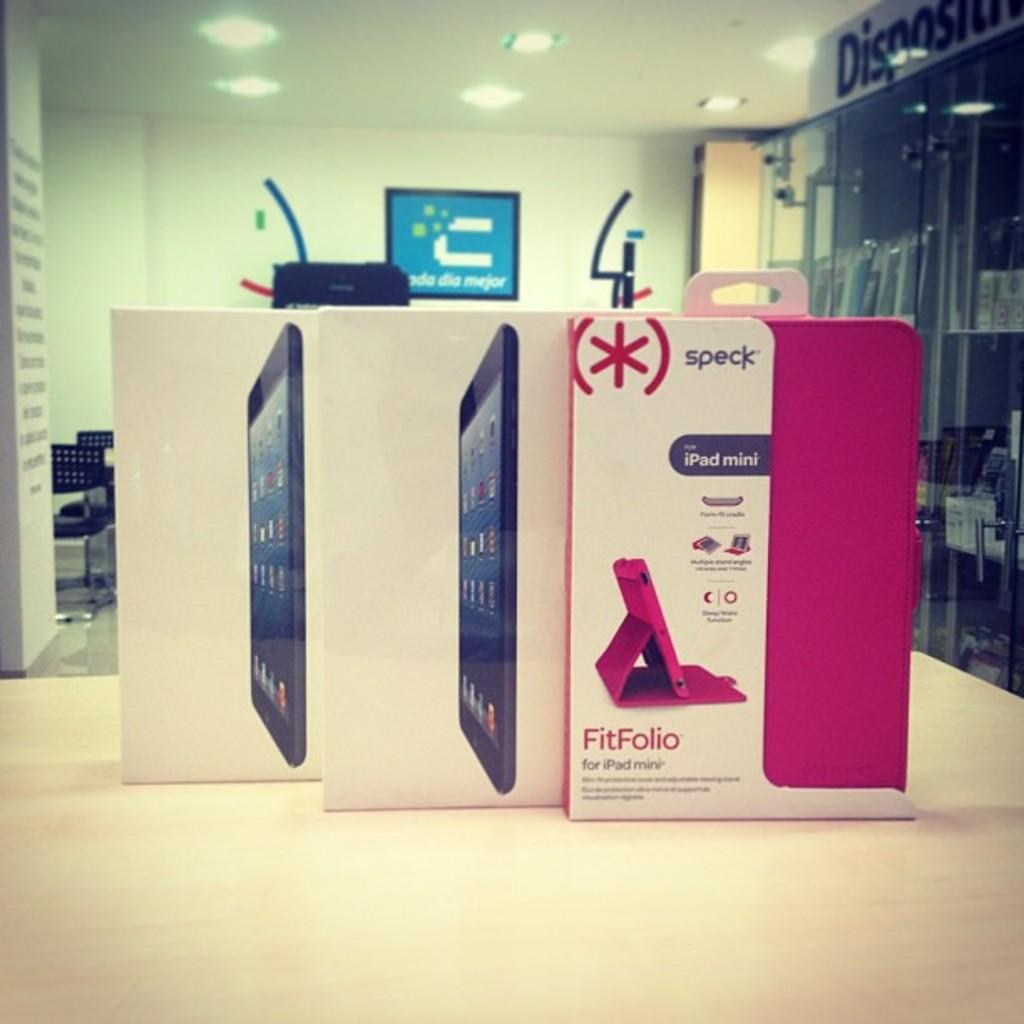<image>
Give a short and clear explanation of the subsequent image. Two boxes for iPads and a box for a speck FitFolio iPad mini cover. 